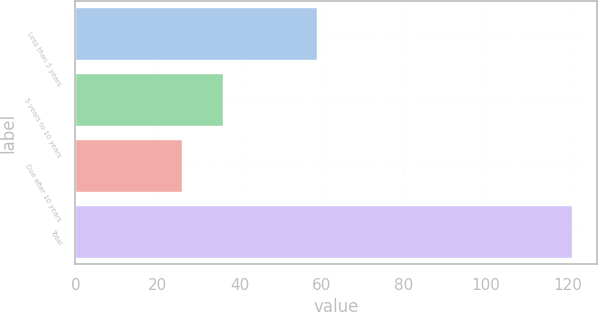Convert chart. <chart><loc_0><loc_0><loc_500><loc_500><bar_chart><fcel>Less than 5 years<fcel>5 years to 10 years<fcel>Due after 10 years<fcel>Total<nl><fcel>59<fcel>36<fcel>26<fcel>121<nl></chart> 